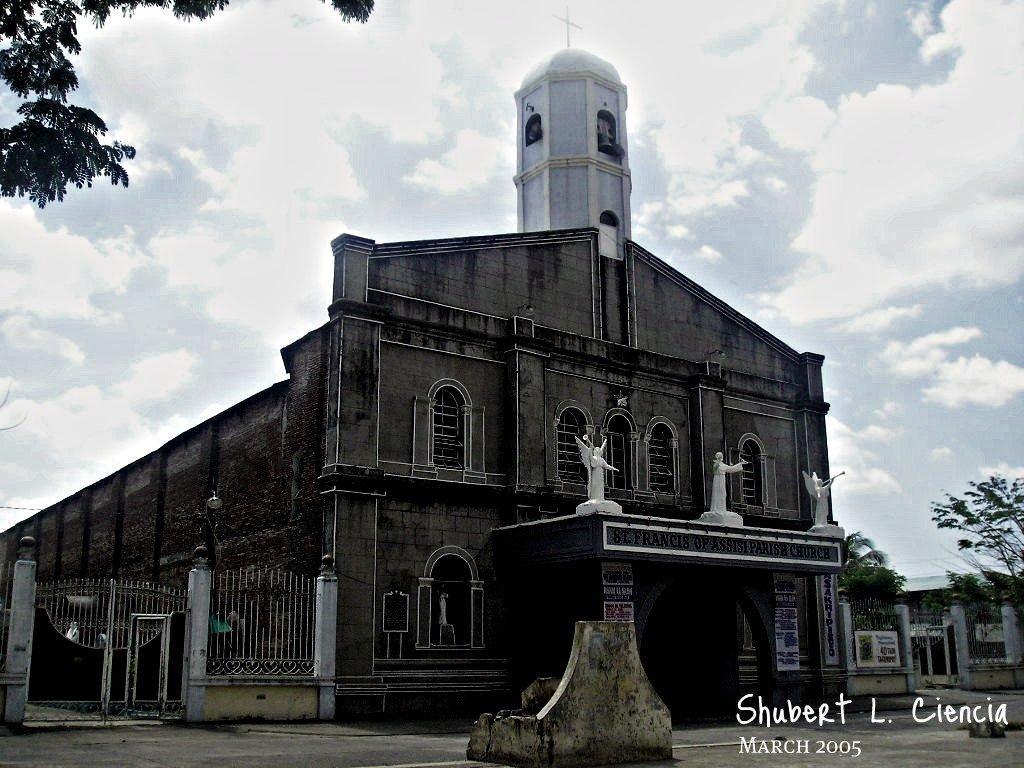Can you describe this image briefly? On the bottom right, there is a watermark. In the middle of this image, there is a building having windows and statues. On the left side, there is a fence and a gate. On the top left, there are branches of a tree having leaves. On the right side, there are trees, a fence, a gate and a shelter. In the background, there are clouds in the sky. 